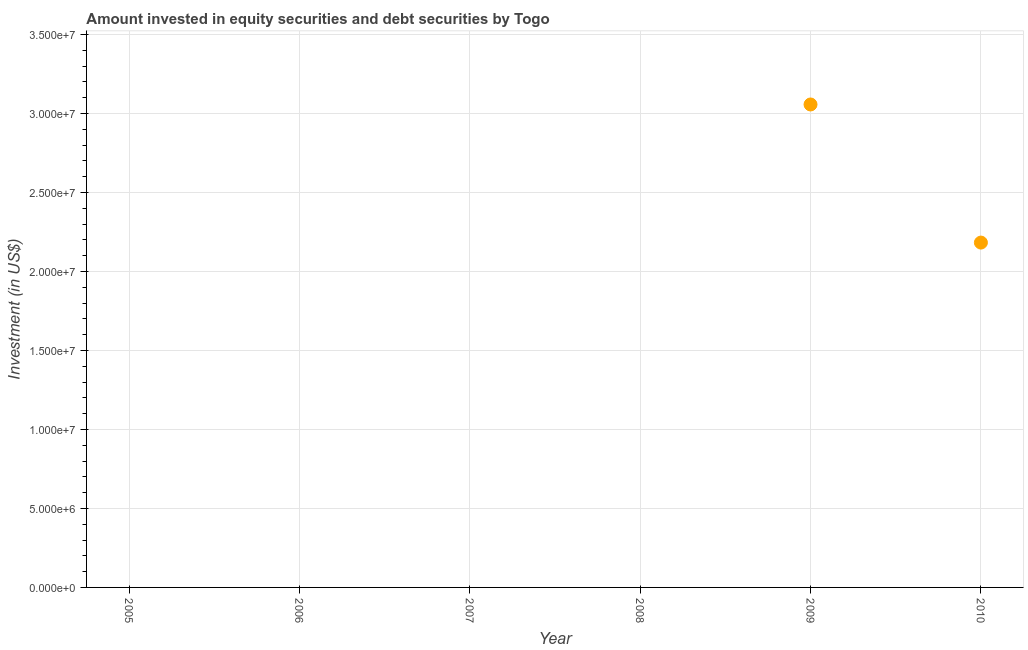What is the portfolio investment in 2010?
Provide a succinct answer. 2.18e+07. Across all years, what is the maximum portfolio investment?
Provide a succinct answer. 3.06e+07. Across all years, what is the minimum portfolio investment?
Give a very brief answer. 0. In which year was the portfolio investment maximum?
Make the answer very short. 2009. What is the sum of the portfolio investment?
Provide a short and direct response. 5.24e+07. What is the difference between the portfolio investment in 2009 and 2010?
Your response must be concise. 8.74e+06. What is the average portfolio investment per year?
Provide a short and direct response. 8.73e+06. What is the median portfolio investment?
Provide a succinct answer. 0. In how many years, is the portfolio investment greater than 9000000 US$?
Your answer should be very brief. 2. Is the portfolio investment in 2009 less than that in 2010?
Offer a terse response. No. Is the difference between the portfolio investment in 2009 and 2010 greater than the difference between any two years?
Ensure brevity in your answer.  No. What is the difference between the highest and the lowest portfolio investment?
Ensure brevity in your answer.  3.06e+07. How many dotlines are there?
Ensure brevity in your answer.  1. What is the difference between two consecutive major ticks on the Y-axis?
Your response must be concise. 5.00e+06. What is the title of the graph?
Offer a terse response. Amount invested in equity securities and debt securities by Togo. What is the label or title of the X-axis?
Give a very brief answer. Year. What is the label or title of the Y-axis?
Your answer should be very brief. Investment (in US$). What is the Investment (in US$) in 2005?
Your answer should be very brief. 0. What is the Investment (in US$) in 2007?
Your response must be concise. 0. What is the Investment (in US$) in 2009?
Ensure brevity in your answer.  3.06e+07. What is the Investment (in US$) in 2010?
Your answer should be compact. 2.18e+07. What is the difference between the Investment (in US$) in 2009 and 2010?
Provide a short and direct response. 8.74e+06. What is the ratio of the Investment (in US$) in 2009 to that in 2010?
Give a very brief answer. 1.4. 